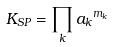<formula> <loc_0><loc_0><loc_500><loc_500>K _ { S P } = \prod _ { k } { a _ { k } } ^ { m _ { k } }</formula> 